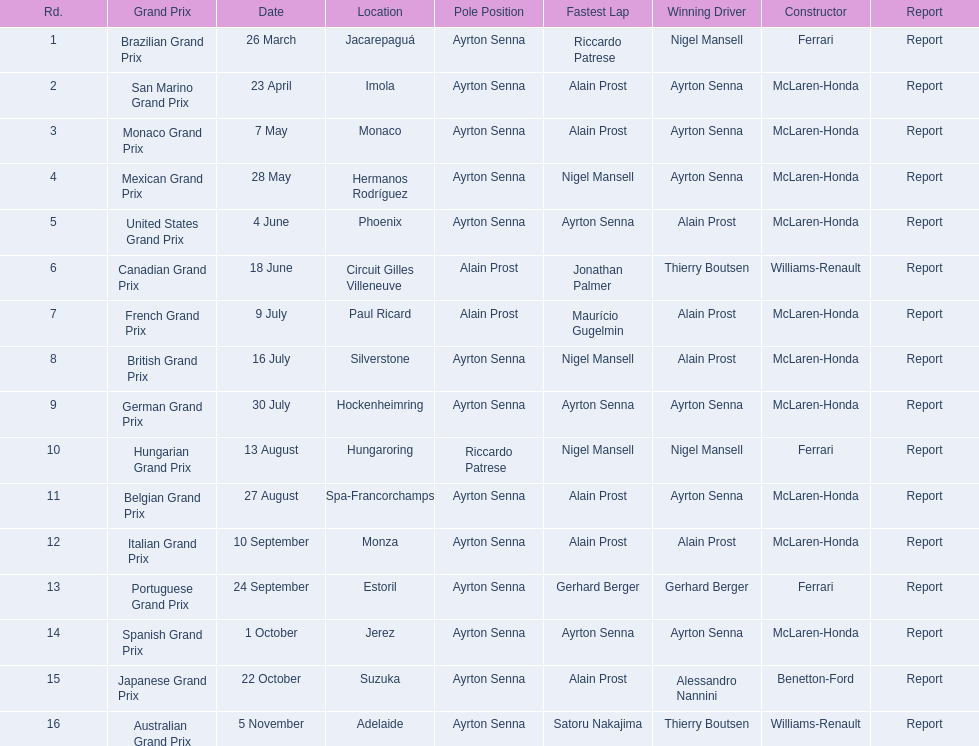Who secured the win in the spanish grand prix? McLaren-Honda. Who was the winner of the italian grand prix? McLaren-Honda. Would you be able to parse every entry in this table? {'header': ['Rd.', 'Grand Prix', 'Date', 'Location', 'Pole Position', 'Fastest Lap', 'Winning Driver', 'Constructor', 'Report'], 'rows': [['1', 'Brazilian Grand Prix', '26 March', 'Jacarepaguá', 'Ayrton Senna', 'Riccardo Patrese', 'Nigel Mansell', 'Ferrari', 'Report'], ['2', 'San Marino Grand Prix', '23 April', 'Imola', 'Ayrton Senna', 'Alain Prost', 'Ayrton Senna', 'McLaren-Honda', 'Report'], ['3', 'Monaco Grand Prix', '7 May', 'Monaco', 'Ayrton Senna', 'Alain Prost', 'Ayrton Senna', 'McLaren-Honda', 'Report'], ['4', 'Mexican Grand Prix', '28 May', 'Hermanos Rodríguez', 'Ayrton Senna', 'Nigel Mansell', 'Ayrton Senna', 'McLaren-Honda', 'Report'], ['5', 'United States Grand Prix', '4 June', 'Phoenix', 'Ayrton Senna', 'Ayrton Senna', 'Alain Prost', 'McLaren-Honda', 'Report'], ['6', 'Canadian Grand Prix', '18 June', 'Circuit Gilles Villeneuve', 'Alain Prost', 'Jonathan Palmer', 'Thierry Boutsen', 'Williams-Renault', 'Report'], ['7', 'French Grand Prix', '9 July', 'Paul Ricard', 'Alain Prost', 'Maurício Gugelmin', 'Alain Prost', 'McLaren-Honda', 'Report'], ['8', 'British Grand Prix', '16 July', 'Silverstone', 'Ayrton Senna', 'Nigel Mansell', 'Alain Prost', 'McLaren-Honda', 'Report'], ['9', 'German Grand Prix', '30 July', 'Hockenheimring', 'Ayrton Senna', 'Ayrton Senna', 'Ayrton Senna', 'McLaren-Honda', 'Report'], ['10', 'Hungarian Grand Prix', '13 August', 'Hungaroring', 'Riccardo Patrese', 'Nigel Mansell', 'Nigel Mansell', 'Ferrari', 'Report'], ['11', 'Belgian Grand Prix', '27 August', 'Spa-Francorchamps', 'Ayrton Senna', 'Alain Prost', 'Ayrton Senna', 'McLaren-Honda', 'Report'], ['12', 'Italian Grand Prix', '10 September', 'Monza', 'Ayrton Senna', 'Alain Prost', 'Alain Prost', 'McLaren-Honda', 'Report'], ['13', 'Portuguese Grand Prix', '24 September', 'Estoril', 'Ayrton Senna', 'Gerhard Berger', 'Gerhard Berger', 'Ferrari', 'Report'], ['14', 'Spanish Grand Prix', '1 October', 'Jerez', 'Ayrton Senna', 'Ayrton Senna', 'Ayrton Senna', 'McLaren-Honda', 'Report'], ['15', 'Japanese Grand Prix', '22 October', 'Suzuka', 'Ayrton Senna', 'Alain Prost', 'Alessandro Nannini', 'Benetton-Ford', 'Report'], ['16', 'Australian Grand Prix', '5 November', 'Adelaide', 'Ayrton Senna', 'Satoru Nakajima', 'Thierry Boutsen', 'Williams-Renault', 'Report']]} What was the grand prix that benneton-ford won? Japanese Grand Prix. 